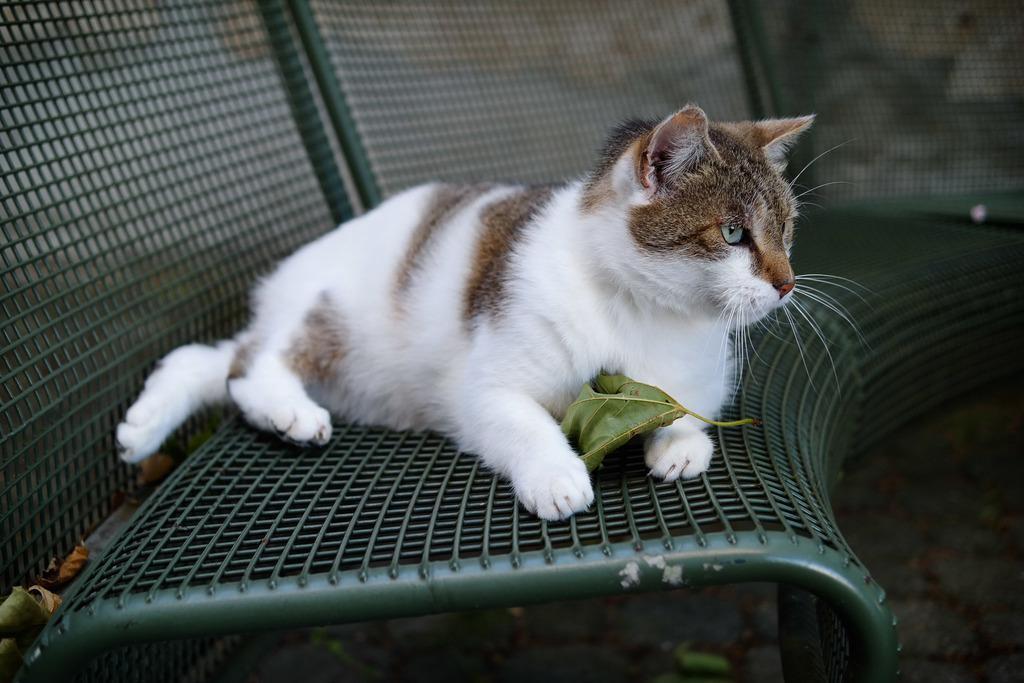Please provide a concise description of this image. In this picture I can observe a cat sitting on the bench in the middle of the picture. The cat is in brown and white color. 